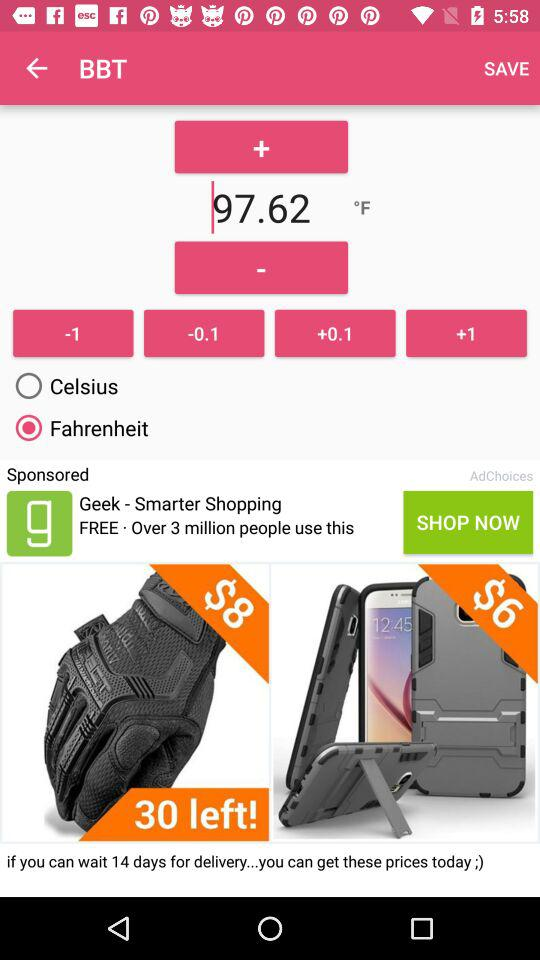What is the difference in price between the gloves and the samsung galaxy s10e case?
Answer the question using a single word or phrase. $2 